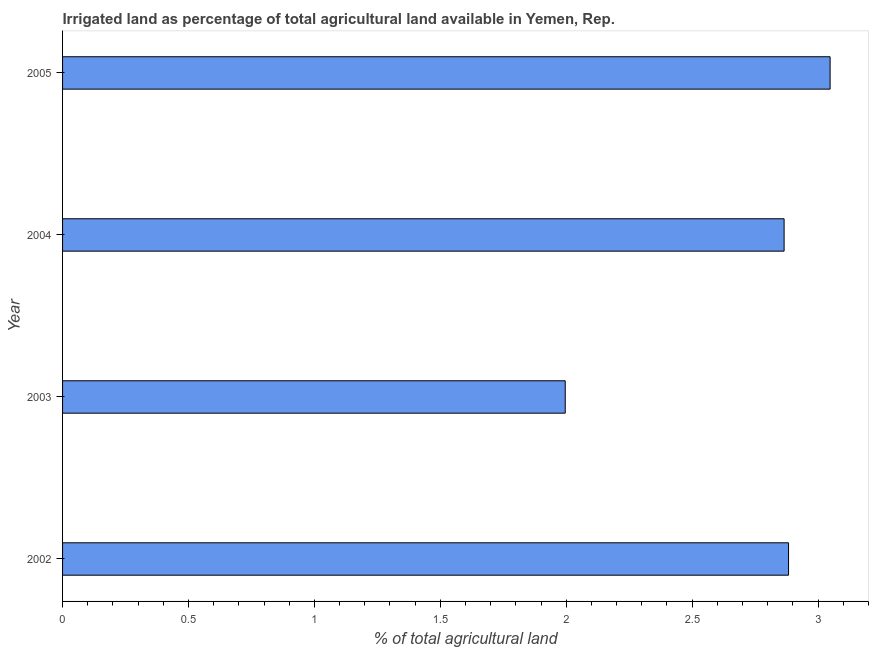What is the title of the graph?
Provide a short and direct response. Irrigated land as percentage of total agricultural land available in Yemen, Rep. What is the label or title of the X-axis?
Offer a terse response. % of total agricultural land. What is the percentage of agricultural irrigated land in 2005?
Offer a terse response. 3.05. Across all years, what is the maximum percentage of agricultural irrigated land?
Give a very brief answer. 3.05. Across all years, what is the minimum percentage of agricultural irrigated land?
Make the answer very short. 2. What is the sum of the percentage of agricultural irrigated land?
Your answer should be very brief. 10.79. What is the difference between the percentage of agricultural irrigated land in 2002 and 2003?
Provide a succinct answer. 0.89. What is the average percentage of agricultural irrigated land per year?
Make the answer very short. 2.7. What is the median percentage of agricultural irrigated land?
Your answer should be compact. 2.87. In how many years, is the percentage of agricultural irrigated land greater than 2.6 %?
Your answer should be compact. 3. What is the ratio of the percentage of agricultural irrigated land in 2002 to that in 2004?
Offer a terse response. 1.01. Is the percentage of agricultural irrigated land in 2003 less than that in 2004?
Make the answer very short. Yes. What is the difference between the highest and the second highest percentage of agricultural irrigated land?
Make the answer very short. 0.17. Is the sum of the percentage of agricultural irrigated land in 2003 and 2005 greater than the maximum percentage of agricultural irrigated land across all years?
Ensure brevity in your answer.  Yes. What is the difference between the highest and the lowest percentage of agricultural irrigated land?
Your response must be concise. 1.05. In how many years, is the percentage of agricultural irrigated land greater than the average percentage of agricultural irrigated land taken over all years?
Provide a short and direct response. 3. How many years are there in the graph?
Your response must be concise. 4. What is the difference between two consecutive major ticks on the X-axis?
Your answer should be very brief. 0.5. What is the % of total agricultural land of 2002?
Provide a short and direct response. 2.88. What is the % of total agricultural land of 2003?
Give a very brief answer. 2. What is the % of total agricultural land in 2004?
Offer a terse response. 2.87. What is the % of total agricultural land in 2005?
Your response must be concise. 3.05. What is the difference between the % of total agricultural land in 2002 and 2003?
Keep it short and to the point. 0.89. What is the difference between the % of total agricultural land in 2002 and 2004?
Provide a short and direct response. 0.02. What is the difference between the % of total agricultural land in 2002 and 2005?
Make the answer very short. -0.17. What is the difference between the % of total agricultural land in 2003 and 2004?
Your response must be concise. -0.87. What is the difference between the % of total agricultural land in 2003 and 2005?
Give a very brief answer. -1.05. What is the difference between the % of total agricultural land in 2004 and 2005?
Give a very brief answer. -0.18. What is the ratio of the % of total agricultural land in 2002 to that in 2003?
Keep it short and to the point. 1.44. What is the ratio of the % of total agricultural land in 2002 to that in 2004?
Ensure brevity in your answer.  1.01. What is the ratio of the % of total agricultural land in 2002 to that in 2005?
Your answer should be very brief. 0.95. What is the ratio of the % of total agricultural land in 2003 to that in 2004?
Keep it short and to the point. 0.7. What is the ratio of the % of total agricultural land in 2003 to that in 2005?
Provide a short and direct response. 0.66. What is the ratio of the % of total agricultural land in 2004 to that in 2005?
Offer a terse response. 0.94. 